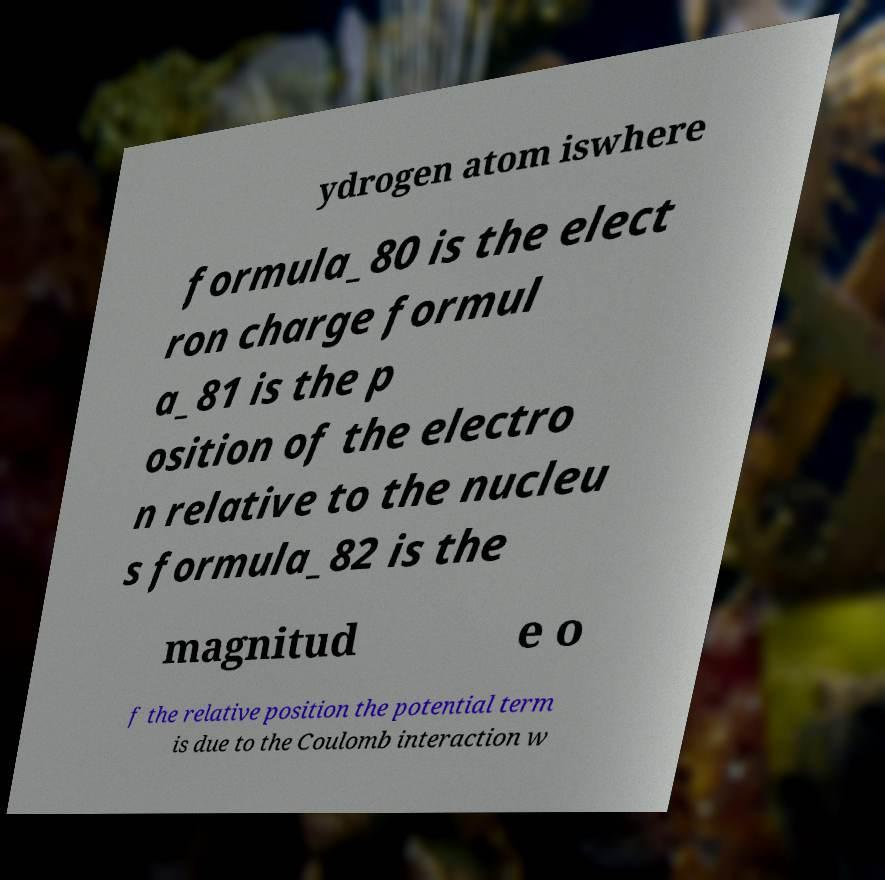I need the written content from this picture converted into text. Can you do that? ydrogen atom iswhere formula_80 is the elect ron charge formul a_81 is the p osition of the electro n relative to the nucleu s formula_82 is the magnitud e o f the relative position the potential term is due to the Coulomb interaction w 